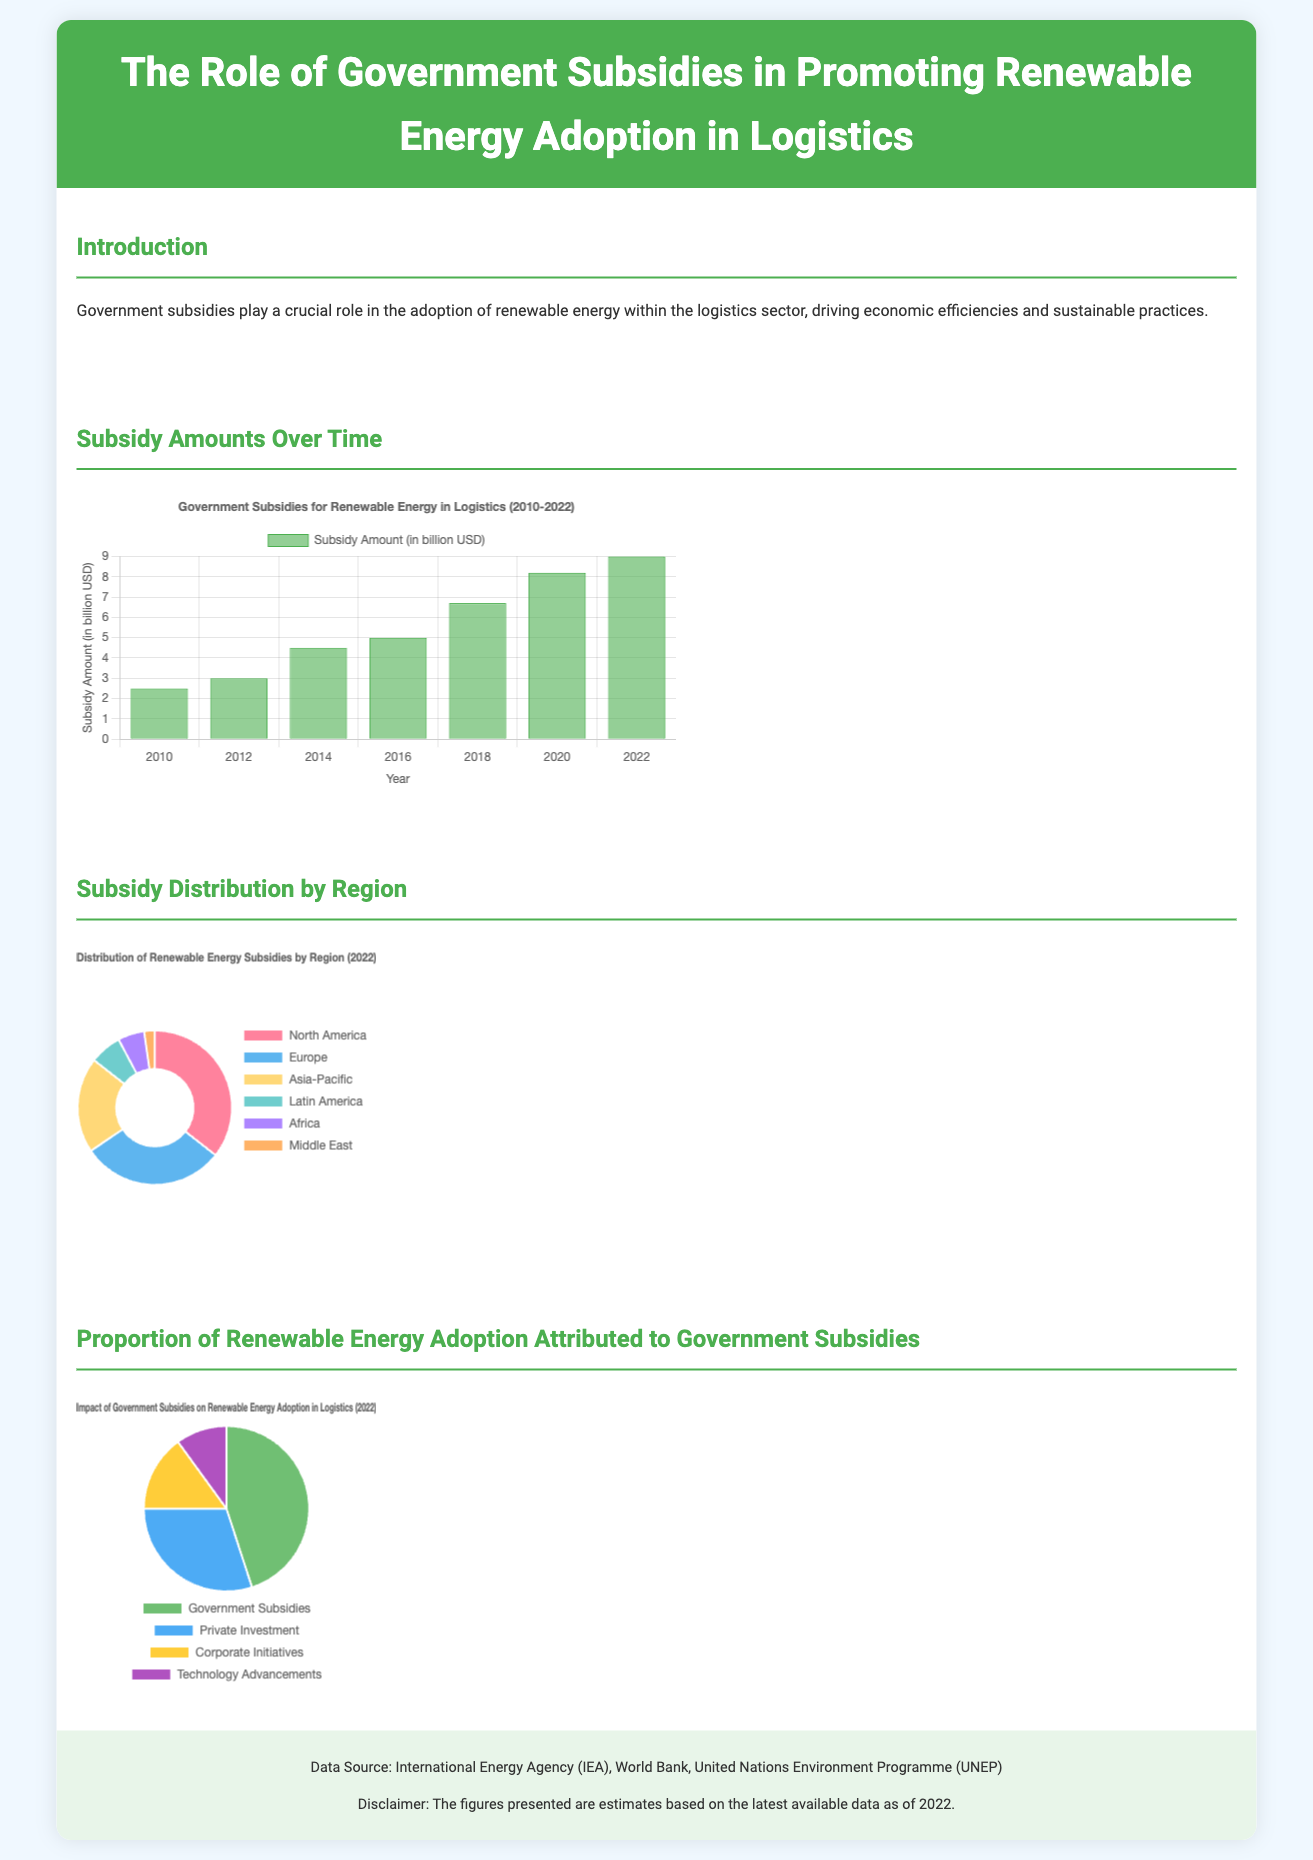What was the subsidy amount in 2022? The subsidy amount in 2022 is listed in the bar chart, which shows an amount of 9.0 billion USD.
Answer: 9.0 billion USD Which region received the highest subsidy amount? The infographic map displays the distribution of subsidies by region, where North America has the highest amount at 3.2 billion USD.
Answer: North America What percentage of renewable energy adoption is attributed to government subsidies? According to the pie chart, government subsidies account for 45 percent of renewable energy adoption.
Answer: 45 percent In which year did the subsidy amount first exceed 5 billion USD? The bar chart indicates that the subsidy amount first exceeded 5 billion USD in 2018.
Answer: 2018 What is the total subsidy amount for Europe in 2022? The regional distribution chart specifies that Europe received 2.7 billion USD in subsidies.
Answer: 2.7 billion USD How many factors contribute to renewable energy adoption according to the pie chart? The pie chart lists four factors contributing to renewable energy adoption.
Answer: Four factors What is the approximate amount of subsidies received by the Asia-Pacific region? The distribution chart shows that the Asia-Pacific region received approximately 1.8 billion USD in subsidies.
Answer: 1.8 billion USD What year shows the highest growth in subsidy amounts compared to the previous year? Examining the bar chart, the year 2020 shows the highest growth in subsidy amounts compared to the previous year.
Answer: 2020 